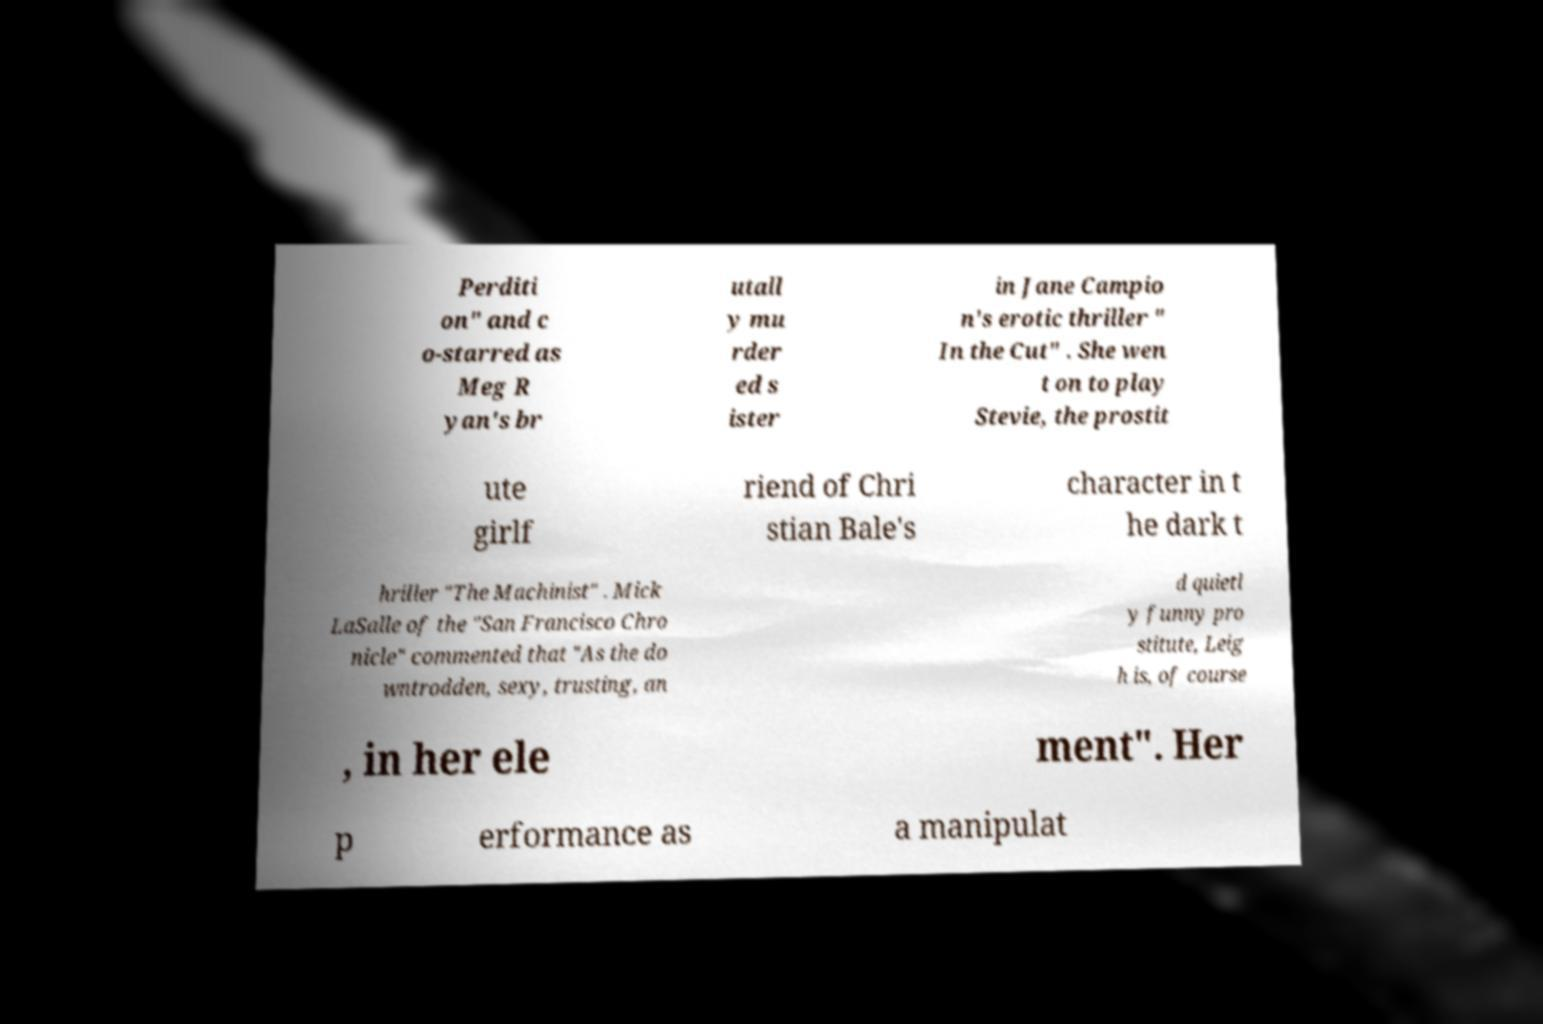Can you read and provide the text displayed in the image?This photo seems to have some interesting text. Can you extract and type it out for me? Perditi on" and c o-starred as Meg R yan's br utall y mu rder ed s ister in Jane Campio n's erotic thriller " In the Cut" . She wen t on to play Stevie, the prostit ute girlf riend of Chri stian Bale's character in t he dark t hriller "The Machinist" . Mick LaSalle of the "San Francisco Chro nicle" commented that "As the do wntrodden, sexy, trusting, an d quietl y funny pro stitute, Leig h is, of course , in her ele ment". Her p erformance as a manipulat 